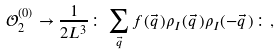Convert formula to latex. <formula><loc_0><loc_0><loc_500><loc_500>\mathcal { O } _ { 2 } ^ { ( 0 ) } \rightarrow \frac { 1 } { 2 L ^ { 3 } } \colon \sum _ { \vec { q } } f ( \vec { q } \, ) \rho _ { I } ( \vec { q } \, ) \rho _ { I } ( - \vec { q } \, ) \colon ,</formula> 